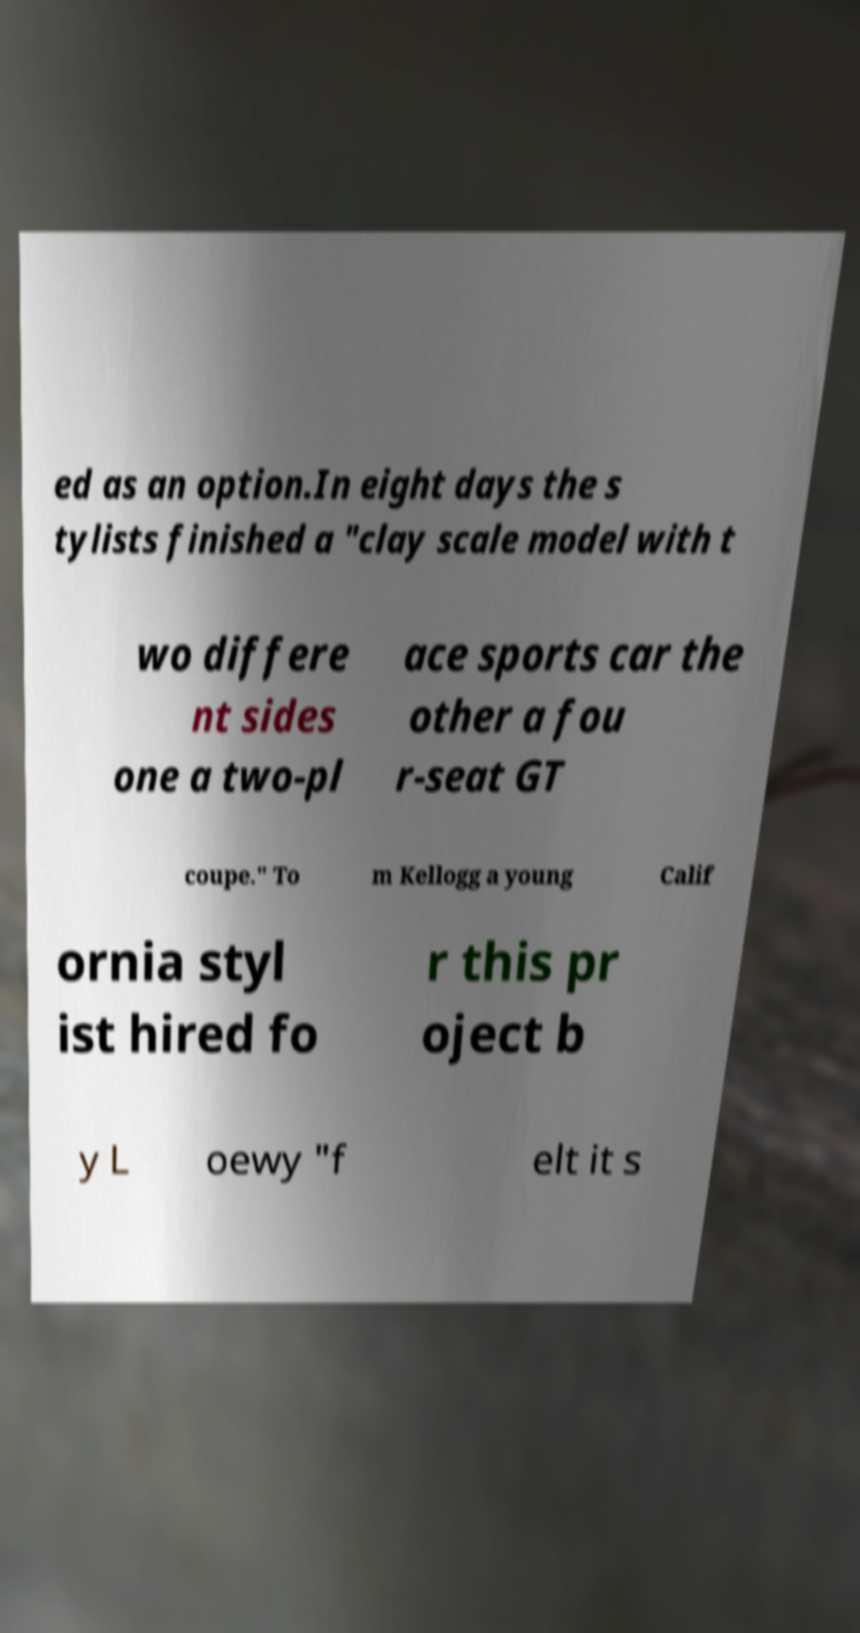I need the written content from this picture converted into text. Can you do that? ed as an option.In eight days the s tylists finished a "clay scale model with t wo differe nt sides one a two-pl ace sports car the other a fou r-seat GT coupe." To m Kellogg a young Calif ornia styl ist hired fo r this pr oject b y L oewy "f elt it s 